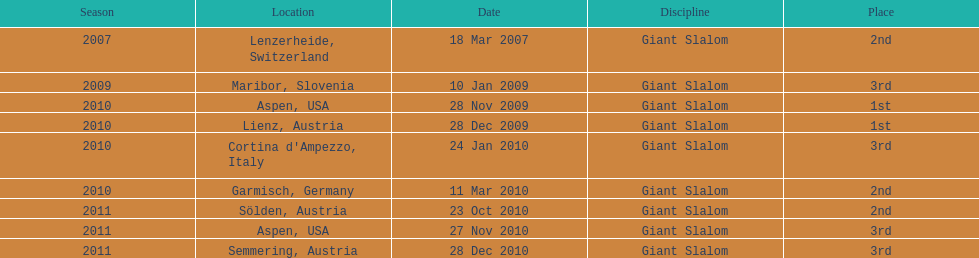What is the only location in the us? Aspen. 